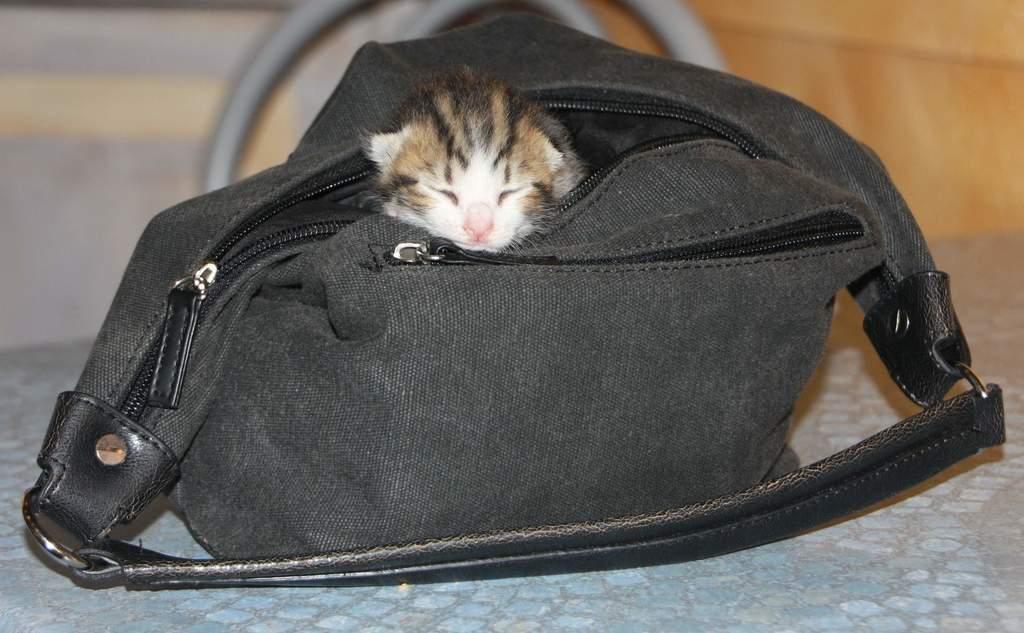Could you give a brief overview of what you see in this image? In this image there is a cat in the bag which is kept on the table. Behind the table there is a chair. Background there is a wall. 